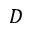Convert formula to latex. <formula><loc_0><loc_0><loc_500><loc_500>D</formula> 